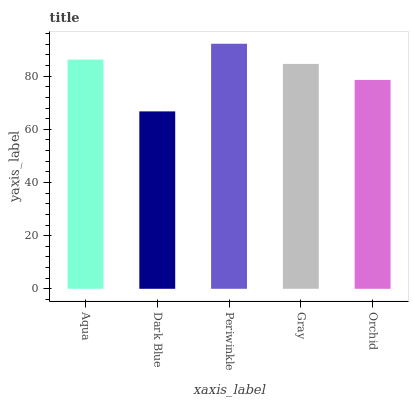Is Dark Blue the minimum?
Answer yes or no. Yes. Is Periwinkle the maximum?
Answer yes or no. Yes. Is Periwinkle the minimum?
Answer yes or no. No. Is Dark Blue the maximum?
Answer yes or no. No. Is Periwinkle greater than Dark Blue?
Answer yes or no. Yes. Is Dark Blue less than Periwinkle?
Answer yes or no. Yes. Is Dark Blue greater than Periwinkle?
Answer yes or no. No. Is Periwinkle less than Dark Blue?
Answer yes or no. No. Is Gray the high median?
Answer yes or no. Yes. Is Gray the low median?
Answer yes or no. Yes. Is Orchid the high median?
Answer yes or no. No. Is Aqua the low median?
Answer yes or no. No. 